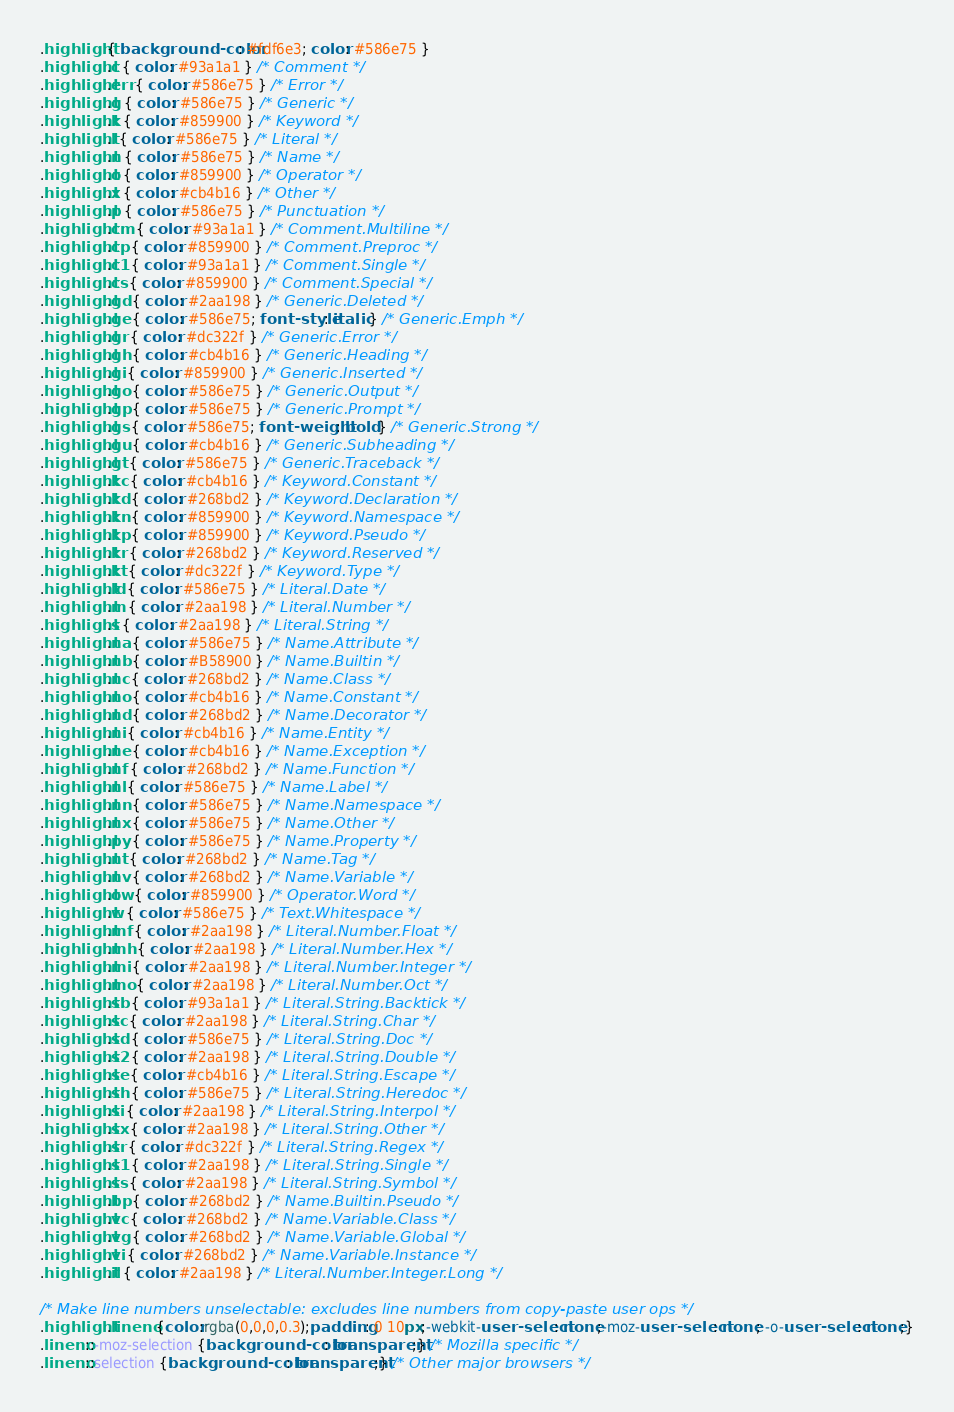Convert code to text. <code><loc_0><loc_0><loc_500><loc_500><_CSS_>.highlight { background-color: #fdf6e3; color: #586e75 }
.highlight .c { color: #93a1a1 } /* Comment */
.highlight .err { color: #586e75 } /* Error */
.highlight .g { color: #586e75 } /* Generic */
.highlight .k { color: #859900 } /* Keyword */
.highlight .l { color: #586e75 } /* Literal */
.highlight .n { color: #586e75 } /* Name */
.highlight .o { color: #859900 } /* Operator */
.highlight .x { color: #cb4b16 } /* Other */
.highlight .p { color: #586e75 } /* Punctuation */
.highlight .cm { color: #93a1a1 } /* Comment.Multiline */
.highlight .cp { color: #859900 } /* Comment.Preproc */
.highlight .c1 { color: #93a1a1 } /* Comment.Single */
.highlight .cs { color: #859900 } /* Comment.Special */
.highlight .gd { color: #2aa198 } /* Generic.Deleted */
.highlight .ge { color: #586e75; font-style: italic } /* Generic.Emph */
.highlight .gr { color: #dc322f } /* Generic.Error */
.highlight .gh { color: #cb4b16 } /* Generic.Heading */
.highlight .gi { color: #859900 } /* Generic.Inserted */
.highlight .go { color: #586e75 } /* Generic.Output */
.highlight .gp { color: #586e75 } /* Generic.Prompt */
.highlight .gs { color: #586e75; font-weight: bold } /* Generic.Strong */
.highlight .gu { color: #cb4b16 } /* Generic.Subheading */
.highlight .gt { color: #586e75 } /* Generic.Traceback */
.highlight .kc { color: #cb4b16 } /* Keyword.Constant */
.highlight .kd { color: #268bd2 } /* Keyword.Declaration */
.highlight .kn { color: #859900 } /* Keyword.Namespace */
.highlight .kp { color: #859900 } /* Keyword.Pseudo */
.highlight .kr { color: #268bd2 } /* Keyword.Reserved */
.highlight .kt { color: #dc322f } /* Keyword.Type */
.highlight .ld { color: #586e75 } /* Literal.Date */
.highlight .m { color: #2aa198 } /* Literal.Number */
.highlight .s { color: #2aa198 } /* Literal.String */
.highlight .na { color: #586e75 } /* Name.Attribute */
.highlight .nb { color: #B58900 } /* Name.Builtin */
.highlight .nc { color: #268bd2 } /* Name.Class */
.highlight .no { color: #cb4b16 } /* Name.Constant */
.highlight .nd { color: #268bd2 } /* Name.Decorator */
.highlight .ni { color: #cb4b16 } /* Name.Entity */
.highlight .ne { color: #cb4b16 } /* Name.Exception */
.highlight .nf { color: #268bd2 } /* Name.Function */
.highlight .nl { color: #586e75 } /* Name.Label */
.highlight .nn { color: #586e75 } /* Name.Namespace */
.highlight .nx { color: #586e75 } /* Name.Other */
.highlight .py { color: #586e75 } /* Name.Property */
.highlight .nt { color: #268bd2 } /* Name.Tag */
.highlight .nv { color: #268bd2 } /* Name.Variable */
.highlight .ow { color: #859900 } /* Operator.Word */
.highlight .w { color: #586e75 } /* Text.Whitespace */
.highlight .mf { color: #2aa198 } /* Literal.Number.Float */
.highlight .mh { color: #2aa198 } /* Literal.Number.Hex */
.highlight .mi { color: #2aa198 } /* Literal.Number.Integer */
.highlight .mo { color: #2aa198 } /* Literal.Number.Oct */
.highlight .sb { color: #93a1a1 } /* Literal.String.Backtick */
.highlight .sc { color: #2aa198 } /* Literal.String.Char */
.highlight .sd { color: #586e75 } /* Literal.String.Doc */
.highlight .s2 { color: #2aa198 } /* Literal.String.Double */
.highlight .se { color: #cb4b16 } /* Literal.String.Escape */
.highlight .sh { color: #586e75 } /* Literal.String.Heredoc */
.highlight .si { color: #2aa198 } /* Literal.String.Interpol */
.highlight .sx { color: #2aa198 } /* Literal.String.Other */
.highlight .sr { color: #dc322f } /* Literal.String.Regex */
.highlight .s1 { color: #2aa198 } /* Literal.String.Single */
.highlight .ss { color: #2aa198 } /* Literal.String.Symbol */
.highlight .bp { color: #268bd2 } /* Name.Builtin.Pseudo */
.highlight .vc { color: #268bd2 } /* Name.Variable.Class */
.highlight .vg { color: #268bd2 } /* Name.Variable.Global */
.highlight .vi { color: #268bd2 } /* Name.Variable.Instance */
.highlight .il { color: #2aa198 } /* Literal.Number.Integer.Long */

/* Make line numbers unselectable: excludes line numbers from copy-paste user ops */
.highlight .lineno {color:rgba(0,0,0,0.3);padding: 0 10px;-webkit-user-select: none;-moz-user-select: none; -o-user-select: none;}
.lineno::-moz-selection {background-color: transparent;} /* Mozilla specific */
.lineno::selection {background-color: transparent;} /* Other major browsers */
</code> 